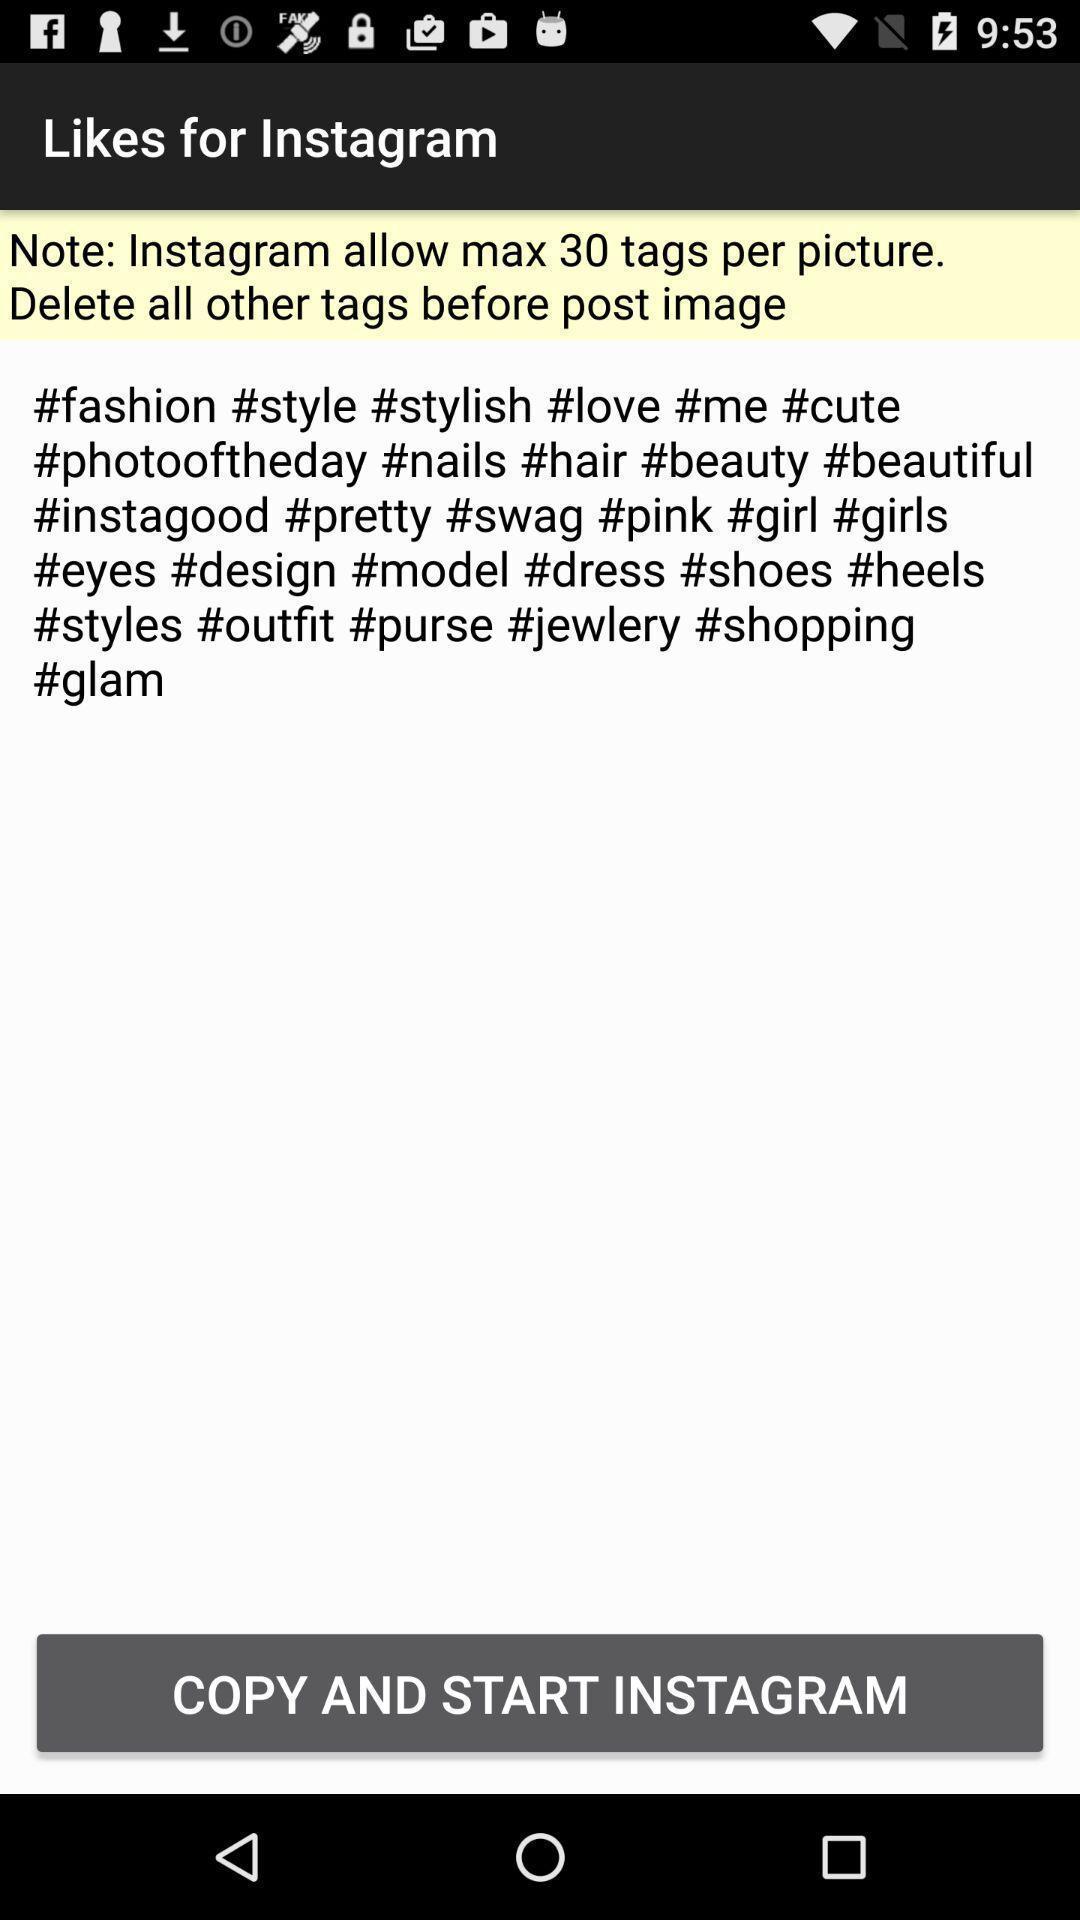Tell me about the visual elements in this screen capture. Page displaying various hash tags in social application. 